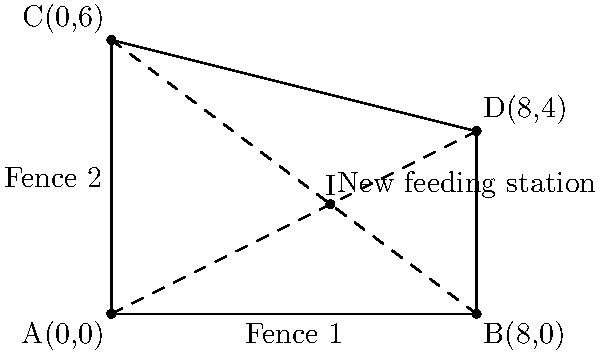Two fences in an animal sanctuary intersect to form a rectangular enclosure. Fence 1 runs along the x-axis from (0,0) to (8,0), while Fence 2 connects points (0,6) and (8,4). To optimize feeding, a new station needs to be placed at the intersection of the diagonals of this enclosure. What are the coordinates of this new feeding station? To find the intersection point of the diagonals, we need to:

1. Identify the coordinates of the rectangle's corners:
   A(0,0), B(8,0), C(0,6), D(8,4)

2. Find the equations of the diagonals:
   Diagonal 1: AC
   Diagonal 2: BD

3. For AC (y = mx + b):
   Slope: $m_{AC} = \frac{6-0}{0-0} = undefined$
   Equation: x = 0

4. For BD (y = mx + b):
   Slope: $m_{BD} = \frac{4-0}{8-0} = \frac{1}{2}$
   y-intercept: $b = 0 - \frac{1}{2}(0) = 0$
   Equation: $y = \frac{1}{2}x$

5. The intersection point (x,y) satisfies both equations:
   $x = 0$ and $y = \frac{1}{2}x$

6. Substituting x = 0 into $y = \frac{1}{2}x$:
   $y = \frac{1}{2}(0) = 0$

Therefore, the intersection point is (0,0).

However, this is clearly not the correct answer as it's one of the corners of the rectangle. Let's try a different approach:

7. Instead of using the diagonal equations, we can find the midpoint of each diagonal:
   Midpoint of AC: $(\frac{0+0}{2}, \frac{0+6}{2}) = (0,3)$
   Midpoint of BD: $(\frac{8+8}{2}, \frac{0+4}{2}) = (8,2)$

8. The line connecting these midpoints will pass through the intersection of the diagonals:
   Slope: $m = \frac{2-3}{8-0} = -\frac{1}{8}$
   Equation: $y - 3 = -\frac{1}{8}(x - 0)$ or $y = -\frac{1}{8}x + 3$

9. The x-coordinate of the intersection point will be halfway between 0 and 8:
   $x = \frac{0+8}{2} = 4$

10. Substitute this x-value into the equation from step 8:
    $y = -\frac{1}{8}(4) + 3 = 2.5$

Thus, the coordinates of the new feeding station are (4, 2.5).
Answer: (4, 2.5) 